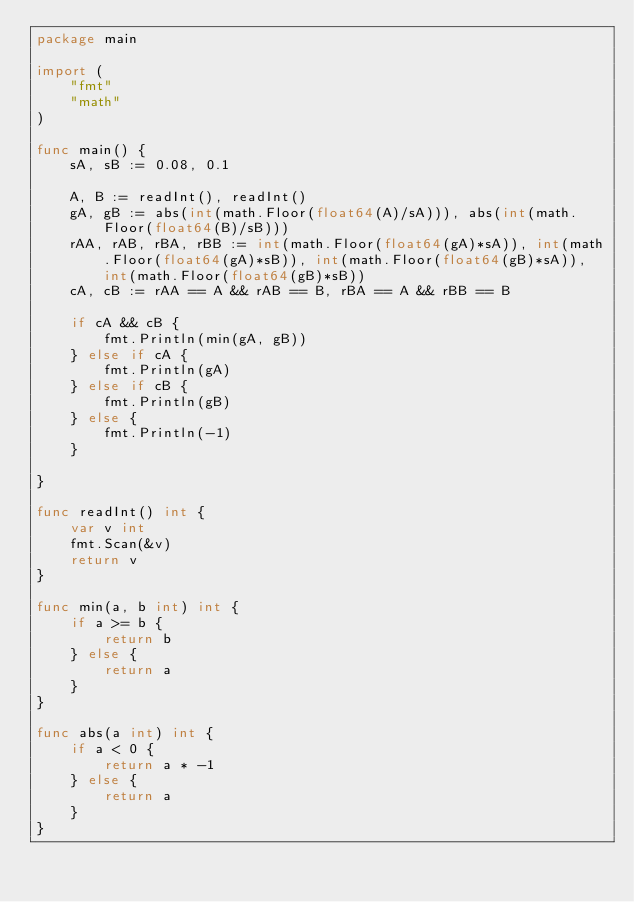<code> <loc_0><loc_0><loc_500><loc_500><_Go_>package main

import (
	"fmt"
	"math"
)

func main() {
	sA, sB := 0.08, 0.1

	A, B := readInt(), readInt()
	gA, gB := abs(int(math.Floor(float64(A)/sA))), abs(int(math.Floor(float64(B)/sB)))
	rAA, rAB, rBA, rBB := int(math.Floor(float64(gA)*sA)), int(math.Floor(float64(gA)*sB)), int(math.Floor(float64(gB)*sA)), int(math.Floor(float64(gB)*sB))
	cA, cB := rAA == A && rAB == B, rBA == A && rBB == B

	if cA && cB {
		fmt.Println(min(gA, gB))
	} else if cA {
		fmt.Println(gA)
	} else if cB {
		fmt.Println(gB)
	} else {
		fmt.Println(-1)
	}

}

func readInt() int {
	var v int
	fmt.Scan(&v)
	return v
}

func min(a, b int) int {
	if a >= b {
		return b
	} else {
		return a
	}
}

func abs(a int) int {
	if a < 0 {
		return a * -1
	} else {
		return a
	}
}</code> 